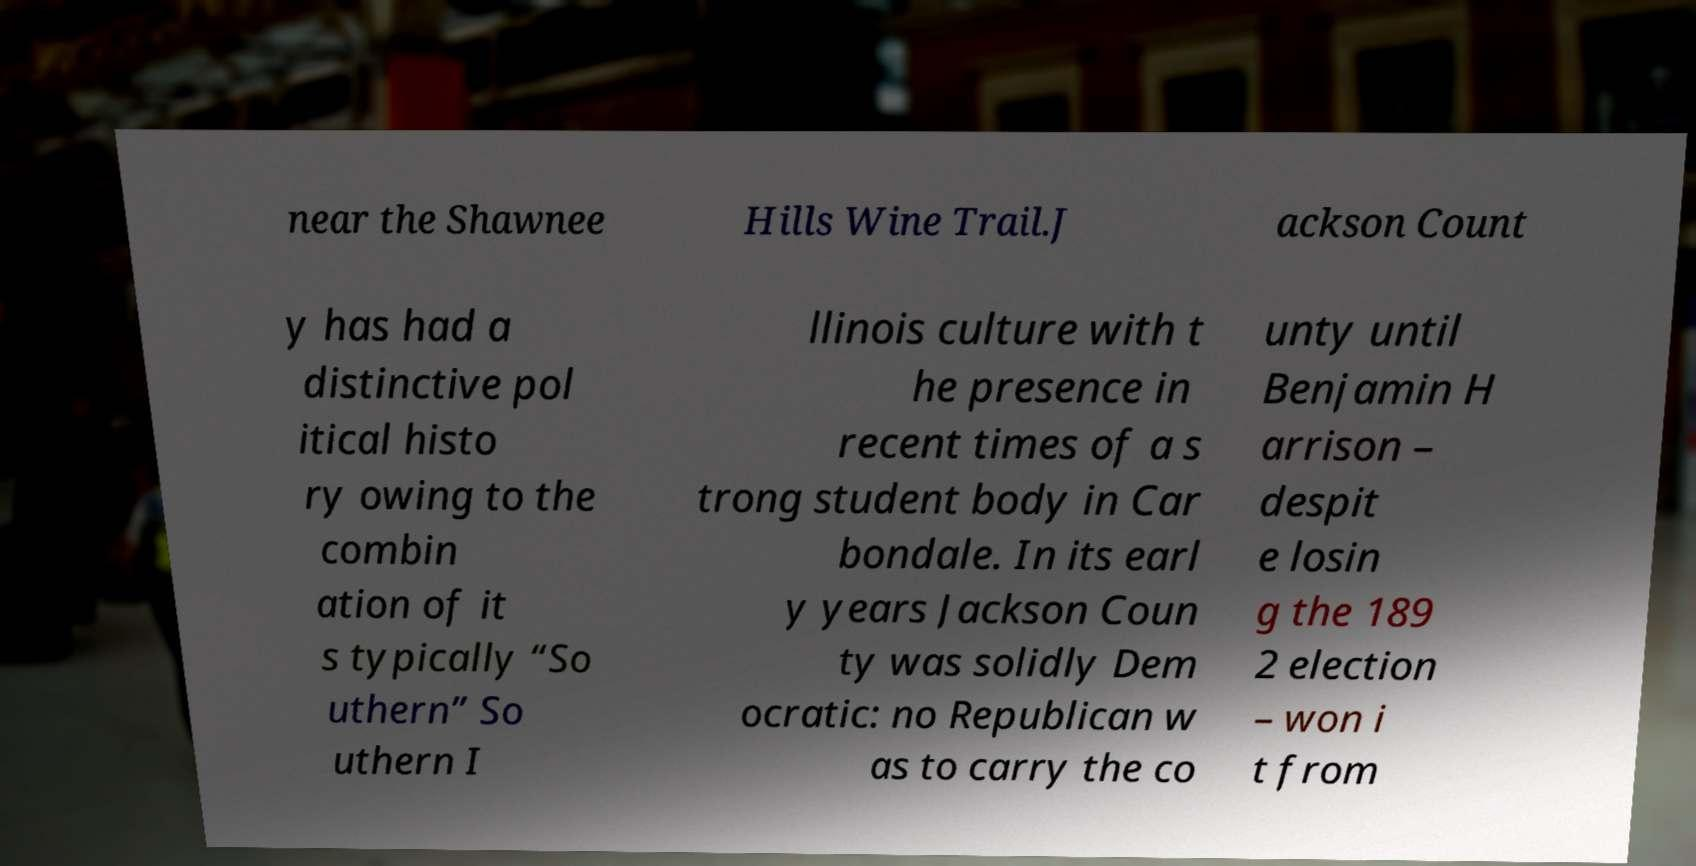Can you accurately transcribe the text from the provided image for me? near the Shawnee Hills Wine Trail.J ackson Count y has had a distinctive pol itical histo ry owing to the combin ation of it s typically “So uthern” So uthern I llinois culture with t he presence in recent times of a s trong student body in Car bondale. In its earl y years Jackson Coun ty was solidly Dem ocratic: no Republican w as to carry the co unty until Benjamin H arrison – despit e losin g the 189 2 election – won i t from 